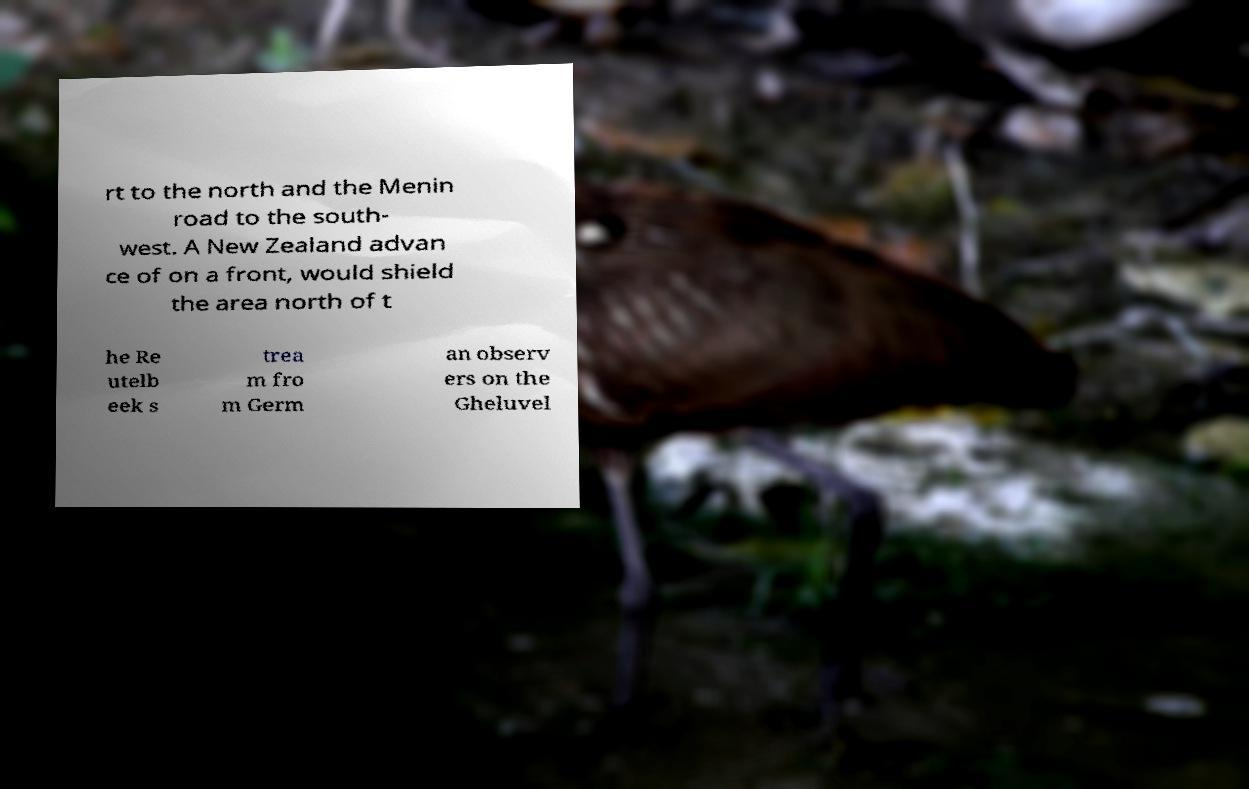There's text embedded in this image that I need extracted. Can you transcribe it verbatim? rt to the north and the Menin road to the south- west. A New Zealand advan ce of on a front, would shield the area north of t he Re utelb eek s trea m fro m Germ an observ ers on the Gheluvel 